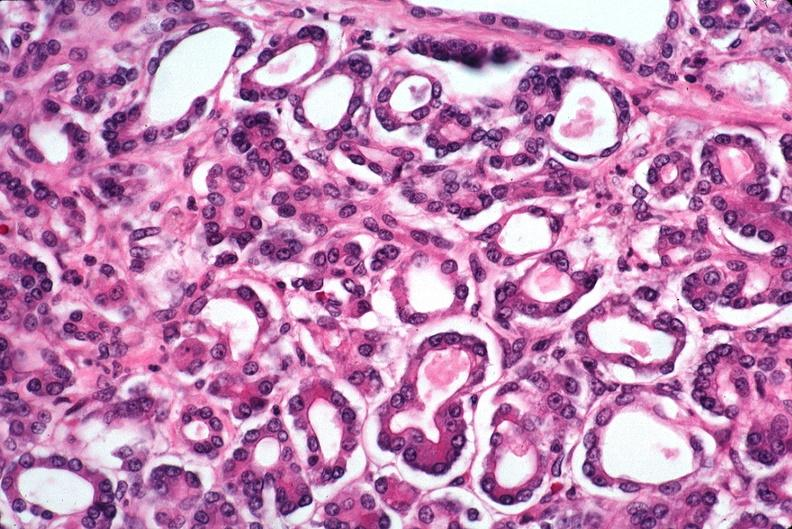does yo show pancreas, uremic pancreatitis due to polycystic kidney?
Answer the question using a single word or phrase. No 